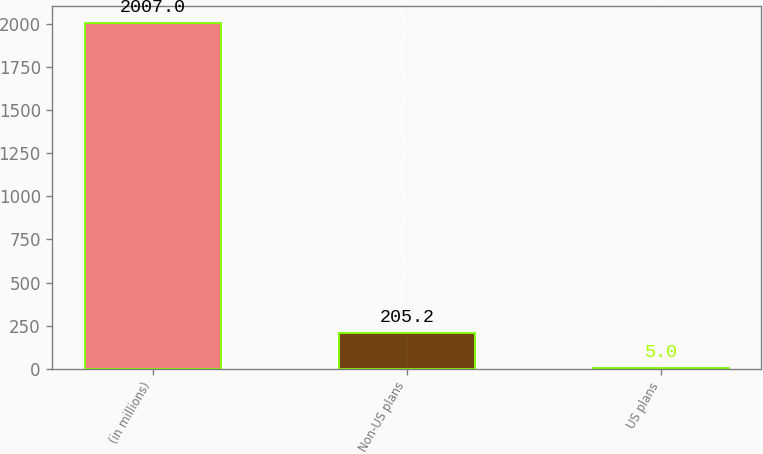Convert chart to OTSL. <chart><loc_0><loc_0><loc_500><loc_500><bar_chart><fcel>(in millions)<fcel>Non-US plans<fcel>US plans<nl><fcel>2007<fcel>205.2<fcel>5<nl></chart> 